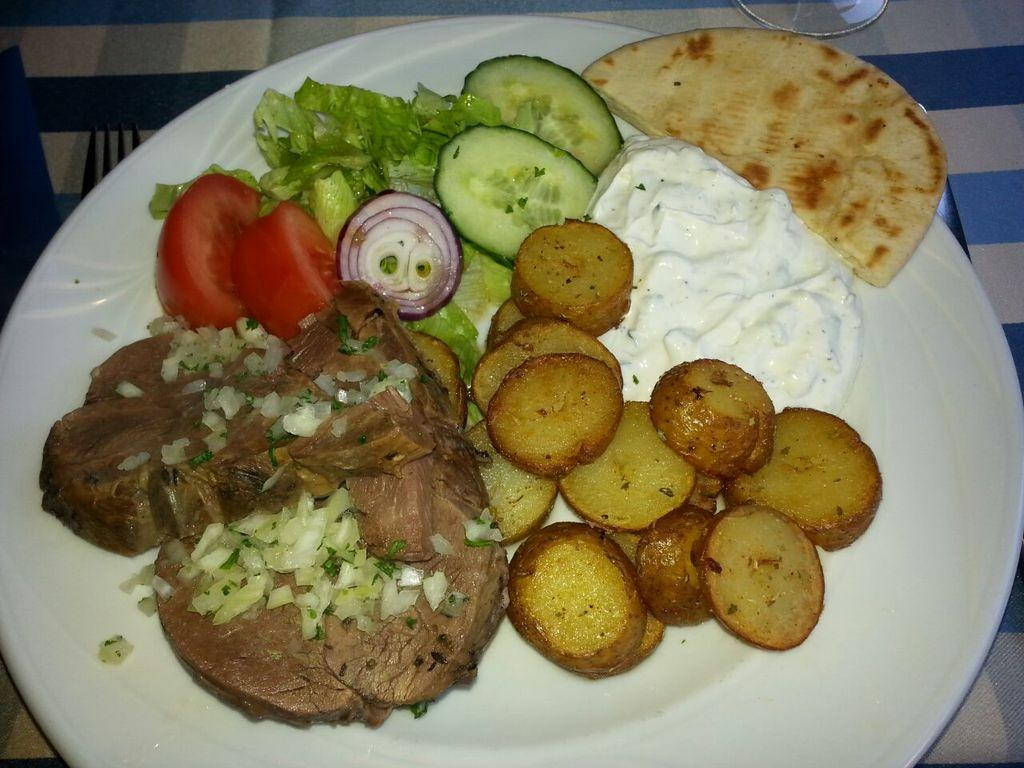What type of furniture is present in the image? There is a table in the image. What is placed on the table? There is a glass, a fork, and a plate on the table. What is on the plate? The plate contains tomato, onion, cabbage, and meat. Are there any other food items on the plate? Yes, there are other food items on the plate. Who is the creator of the committee depicted on the plate? There is no committee depicted on the plate; it contains food items such as tomato, onion, cabbage, and meat. 